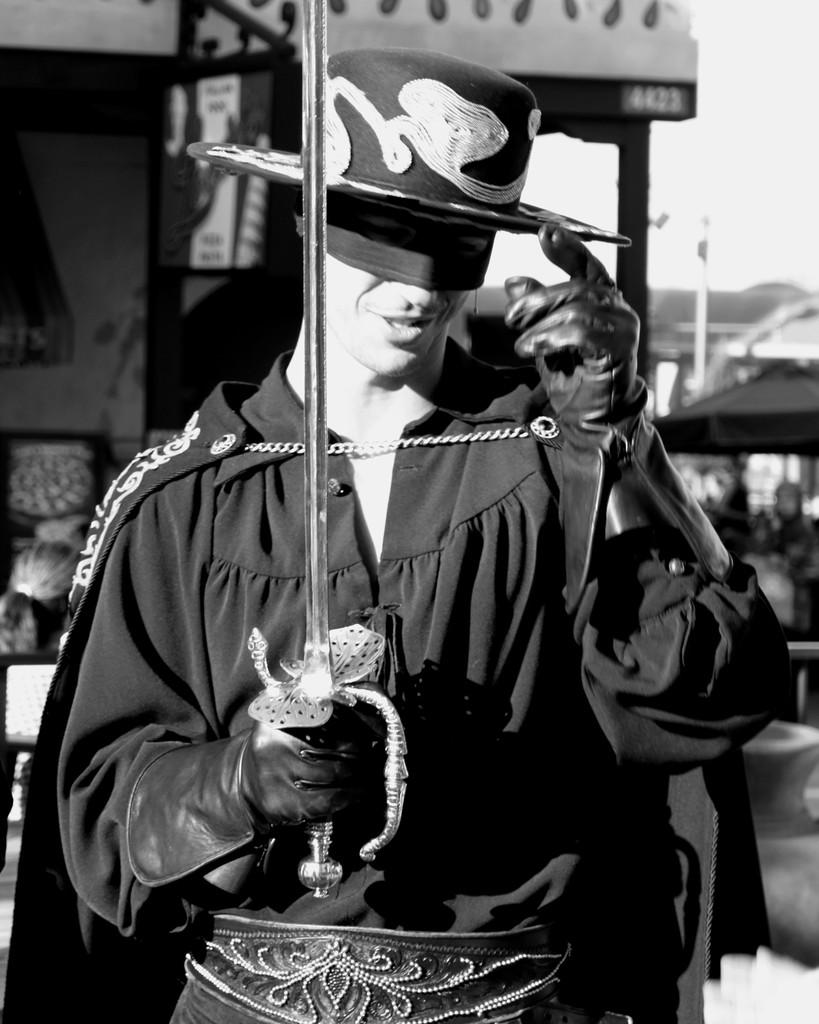What is the main subject of the image? The main subject of the image is a man. What is the man doing in the image? The man is standing in the image. What is the man holding in the image? The man is holding a sword in the image. Can you describe the man's attire in the image? The man is wearing a black dress, a cape, a hat, a mask, and a glove in the image. What can be seen in the background of the image? There are buildings and people in the background of the image. Where is the zoo located in the image? There is no zoo present in the image. What type of food is being served in the lunchroom in the image? There is no lunchroom present in the image. 